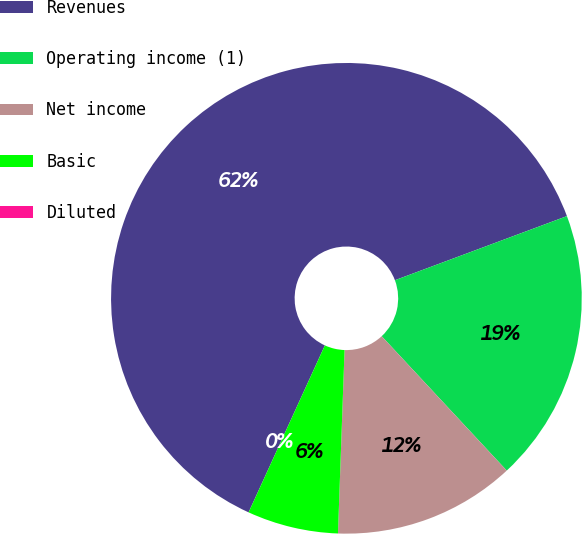Convert chart. <chart><loc_0><loc_0><loc_500><loc_500><pie_chart><fcel>Revenues<fcel>Operating income (1)<fcel>Net income<fcel>Basic<fcel>Diluted<nl><fcel>62.5%<fcel>18.75%<fcel>12.5%<fcel>6.25%<fcel>0.0%<nl></chart> 